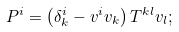<formula> <loc_0><loc_0><loc_500><loc_500>P ^ { i } = \left ( \delta ^ { i } _ { k } - v ^ { i } v _ { k } \right ) T ^ { k l } v _ { l } ;</formula> 